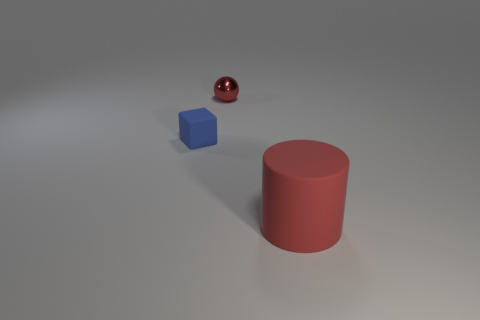Is there anything else that has the same material as the small sphere?
Make the answer very short. No. How many matte objects are large cylinders or blue objects?
Give a very brief answer. 2. How many small red objects are behind the rubber thing in front of the blue block?
Provide a succinct answer. 1. What number of large green blocks are made of the same material as the blue thing?
Offer a terse response. 0. How many big objects are green matte things or red metal spheres?
Offer a very short reply. 0. What is the shape of the thing that is behind the big red object and in front of the sphere?
Offer a very short reply. Cube. Does the large cylinder have the same material as the tiny red object?
Ensure brevity in your answer.  No. The matte block that is the same size as the shiny sphere is what color?
Your answer should be very brief. Blue. What color is the thing that is both to the left of the red matte thing and in front of the red shiny thing?
Ensure brevity in your answer.  Blue. There is a cylinder that is the same color as the metal sphere; what is its size?
Give a very brief answer. Large. 